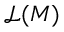Convert formula to latex. <formula><loc_0><loc_0><loc_500><loc_500>{ \mathcal { L } } ( M )</formula> 